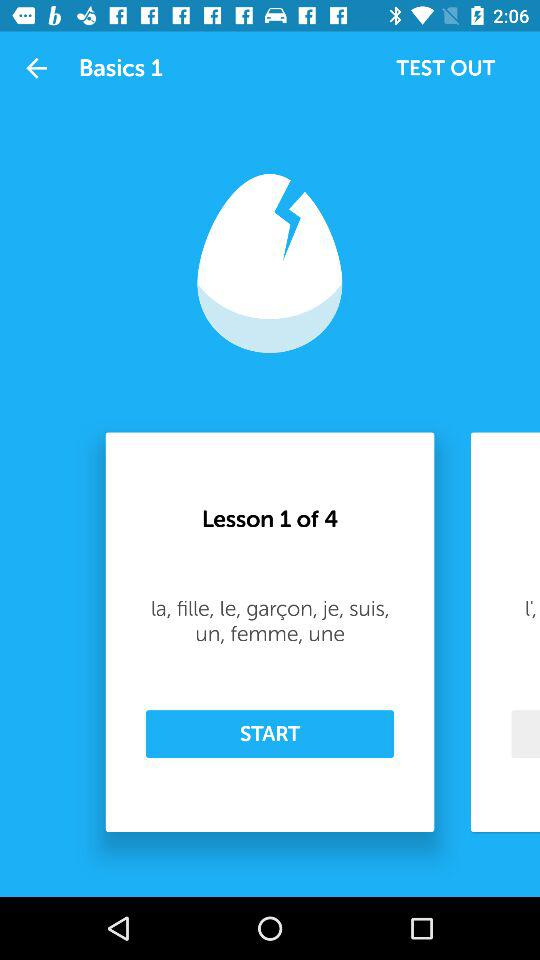How many lessons in total are there? There are 4 lessons in total. 